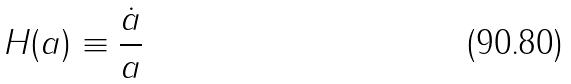<formula> <loc_0><loc_0><loc_500><loc_500>H ( a ) \equiv \frac { \dot { a } } { a }</formula> 